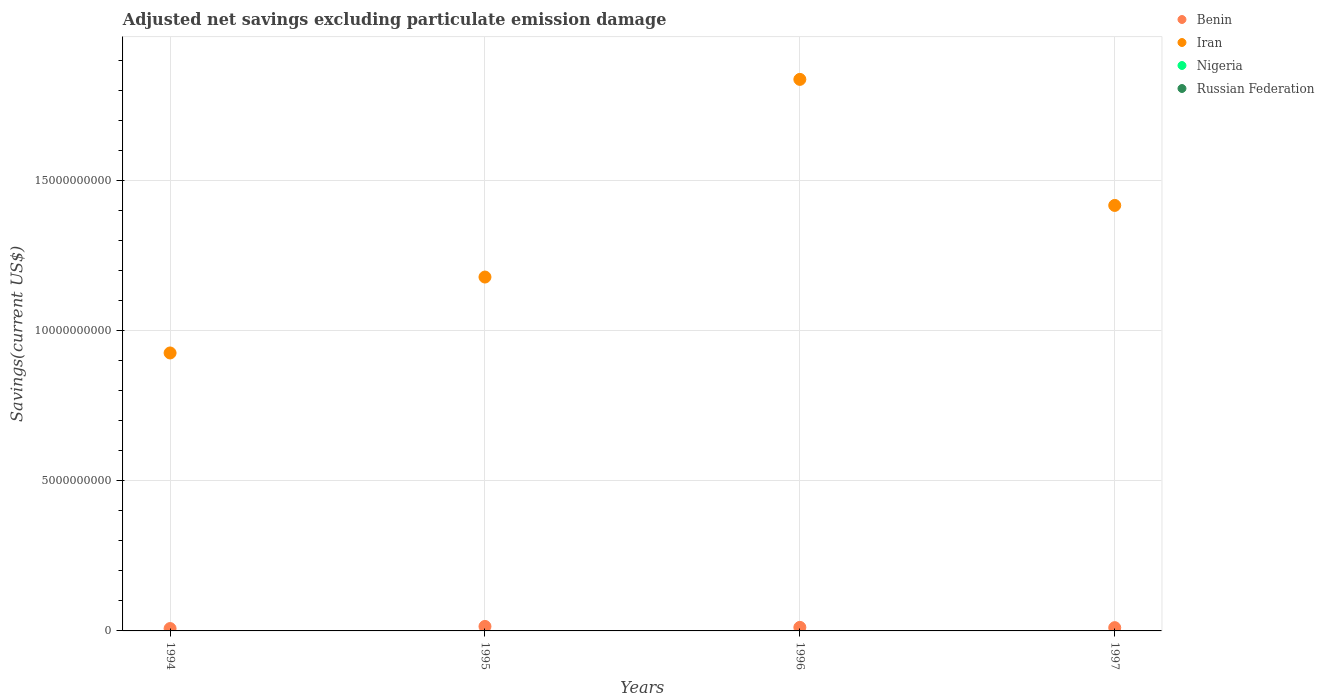How many different coloured dotlines are there?
Make the answer very short. 2. Is the number of dotlines equal to the number of legend labels?
Give a very brief answer. No. What is the adjusted net savings in Iran in 1995?
Provide a short and direct response. 1.18e+1. Across all years, what is the maximum adjusted net savings in Iran?
Your response must be concise. 1.84e+1. Across all years, what is the minimum adjusted net savings in Iran?
Offer a terse response. 9.26e+09. In which year was the adjusted net savings in Iran maximum?
Provide a succinct answer. 1996. What is the total adjusted net savings in Nigeria in the graph?
Ensure brevity in your answer.  0. What is the difference between the adjusted net savings in Benin in 1994 and that in 1995?
Offer a terse response. -7.04e+07. What is the difference between the adjusted net savings in Benin in 1994 and the adjusted net savings in Russian Federation in 1997?
Offer a very short reply. 7.89e+07. In the year 1996, what is the difference between the adjusted net savings in Benin and adjusted net savings in Iran?
Give a very brief answer. -1.82e+1. In how many years, is the adjusted net savings in Iran greater than 14000000000 US$?
Offer a terse response. 2. What is the ratio of the adjusted net savings in Benin in 1994 to that in 1996?
Your answer should be compact. 0.67. What is the difference between the highest and the second highest adjusted net savings in Iran?
Your answer should be very brief. 4.20e+09. What is the difference between the highest and the lowest adjusted net savings in Benin?
Give a very brief answer. 7.04e+07. In how many years, is the adjusted net savings in Benin greater than the average adjusted net savings in Benin taken over all years?
Provide a short and direct response. 2. Does the adjusted net savings in Russian Federation monotonically increase over the years?
Your answer should be compact. No. Is the adjusted net savings in Iran strictly greater than the adjusted net savings in Russian Federation over the years?
Offer a terse response. Yes. Is the adjusted net savings in Nigeria strictly less than the adjusted net savings in Benin over the years?
Give a very brief answer. Yes. What is the difference between two consecutive major ticks on the Y-axis?
Ensure brevity in your answer.  5.00e+09. Are the values on the major ticks of Y-axis written in scientific E-notation?
Your response must be concise. No. Does the graph contain grids?
Offer a very short reply. Yes. How many legend labels are there?
Your response must be concise. 4. What is the title of the graph?
Keep it short and to the point. Adjusted net savings excluding particulate emission damage. What is the label or title of the Y-axis?
Ensure brevity in your answer.  Savings(current US$). What is the Savings(current US$) in Benin in 1994?
Ensure brevity in your answer.  7.89e+07. What is the Savings(current US$) in Iran in 1994?
Provide a short and direct response. 9.26e+09. What is the Savings(current US$) in Russian Federation in 1994?
Offer a terse response. 0. What is the Savings(current US$) in Benin in 1995?
Keep it short and to the point. 1.49e+08. What is the Savings(current US$) of Iran in 1995?
Make the answer very short. 1.18e+1. What is the Savings(current US$) of Benin in 1996?
Offer a terse response. 1.18e+08. What is the Savings(current US$) of Iran in 1996?
Make the answer very short. 1.84e+1. What is the Savings(current US$) in Russian Federation in 1996?
Your answer should be compact. 0. What is the Savings(current US$) in Benin in 1997?
Keep it short and to the point. 1.09e+08. What is the Savings(current US$) in Iran in 1997?
Make the answer very short. 1.42e+1. What is the Savings(current US$) in Nigeria in 1997?
Ensure brevity in your answer.  0. What is the Savings(current US$) in Russian Federation in 1997?
Offer a very short reply. 0. Across all years, what is the maximum Savings(current US$) of Benin?
Your answer should be compact. 1.49e+08. Across all years, what is the maximum Savings(current US$) in Iran?
Keep it short and to the point. 1.84e+1. Across all years, what is the minimum Savings(current US$) in Benin?
Make the answer very short. 7.89e+07. Across all years, what is the minimum Savings(current US$) of Iran?
Make the answer very short. 9.26e+09. What is the total Savings(current US$) in Benin in the graph?
Keep it short and to the point. 4.55e+08. What is the total Savings(current US$) of Iran in the graph?
Your answer should be very brief. 5.36e+1. What is the total Savings(current US$) in Nigeria in the graph?
Keep it short and to the point. 0. What is the total Savings(current US$) of Russian Federation in the graph?
Your response must be concise. 0. What is the difference between the Savings(current US$) of Benin in 1994 and that in 1995?
Provide a short and direct response. -7.04e+07. What is the difference between the Savings(current US$) of Iran in 1994 and that in 1995?
Make the answer very short. -2.53e+09. What is the difference between the Savings(current US$) in Benin in 1994 and that in 1996?
Make the answer very short. -3.92e+07. What is the difference between the Savings(current US$) in Iran in 1994 and that in 1996?
Your answer should be compact. -9.11e+09. What is the difference between the Savings(current US$) of Benin in 1994 and that in 1997?
Offer a terse response. -2.98e+07. What is the difference between the Savings(current US$) in Iran in 1994 and that in 1997?
Offer a terse response. -4.91e+09. What is the difference between the Savings(current US$) in Benin in 1995 and that in 1996?
Your answer should be compact. 3.12e+07. What is the difference between the Savings(current US$) of Iran in 1995 and that in 1996?
Keep it short and to the point. -6.58e+09. What is the difference between the Savings(current US$) in Benin in 1995 and that in 1997?
Give a very brief answer. 4.06e+07. What is the difference between the Savings(current US$) in Iran in 1995 and that in 1997?
Your response must be concise. -2.39e+09. What is the difference between the Savings(current US$) of Benin in 1996 and that in 1997?
Provide a short and direct response. 9.37e+06. What is the difference between the Savings(current US$) of Iran in 1996 and that in 1997?
Give a very brief answer. 4.20e+09. What is the difference between the Savings(current US$) in Benin in 1994 and the Savings(current US$) in Iran in 1995?
Make the answer very short. -1.17e+1. What is the difference between the Savings(current US$) in Benin in 1994 and the Savings(current US$) in Iran in 1996?
Keep it short and to the point. -1.83e+1. What is the difference between the Savings(current US$) of Benin in 1994 and the Savings(current US$) of Iran in 1997?
Offer a very short reply. -1.41e+1. What is the difference between the Savings(current US$) of Benin in 1995 and the Savings(current US$) of Iran in 1996?
Offer a terse response. -1.82e+1. What is the difference between the Savings(current US$) of Benin in 1995 and the Savings(current US$) of Iran in 1997?
Ensure brevity in your answer.  -1.40e+1. What is the difference between the Savings(current US$) in Benin in 1996 and the Savings(current US$) in Iran in 1997?
Ensure brevity in your answer.  -1.41e+1. What is the average Savings(current US$) of Benin per year?
Keep it short and to the point. 1.14e+08. What is the average Savings(current US$) in Iran per year?
Your response must be concise. 1.34e+1. What is the average Savings(current US$) of Nigeria per year?
Offer a very short reply. 0. What is the average Savings(current US$) of Russian Federation per year?
Give a very brief answer. 0. In the year 1994, what is the difference between the Savings(current US$) of Benin and Savings(current US$) of Iran?
Offer a terse response. -9.18e+09. In the year 1995, what is the difference between the Savings(current US$) in Benin and Savings(current US$) in Iran?
Your response must be concise. -1.16e+1. In the year 1996, what is the difference between the Savings(current US$) in Benin and Savings(current US$) in Iran?
Give a very brief answer. -1.82e+1. In the year 1997, what is the difference between the Savings(current US$) of Benin and Savings(current US$) of Iran?
Your response must be concise. -1.41e+1. What is the ratio of the Savings(current US$) in Benin in 1994 to that in 1995?
Your answer should be very brief. 0.53. What is the ratio of the Savings(current US$) of Iran in 1994 to that in 1995?
Give a very brief answer. 0.79. What is the ratio of the Savings(current US$) in Benin in 1994 to that in 1996?
Offer a very short reply. 0.67. What is the ratio of the Savings(current US$) of Iran in 1994 to that in 1996?
Keep it short and to the point. 0.5. What is the ratio of the Savings(current US$) in Benin in 1994 to that in 1997?
Keep it short and to the point. 0.73. What is the ratio of the Savings(current US$) in Iran in 1994 to that in 1997?
Offer a terse response. 0.65. What is the ratio of the Savings(current US$) in Benin in 1995 to that in 1996?
Your answer should be compact. 1.26. What is the ratio of the Savings(current US$) in Iran in 1995 to that in 1996?
Give a very brief answer. 0.64. What is the ratio of the Savings(current US$) of Benin in 1995 to that in 1997?
Give a very brief answer. 1.37. What is the ratio of the Savings(current US$) in Iran in 1995 to that in 1997?
Give a very brief answer. 0.83. What is the ratio of the Savings(current US$) of Benin in 1996 to that in 1997?
Give a very brief answer. 1.09. What is the ratio of the Savings(current US$) of Iran in 1996 to that in 1997?
Provide a succinct answer. 1.3. What is the difference between the highest and the second highest Savings(current US$) in Benin?
Offer a terse response. 3.12e+07. What is the difference between the highest and the second highest Savings(current US$) of Iran?
Offer a terse response. 4.20e+09. What is the difference between the highest and the lowest Savings(current US$) in Benin?
Provide a succinct answer. 7.04e+07. What is the difference between the highest and the lowest Savings(current US$) in Iran?
Make the answer very short. 9.11e+09. 